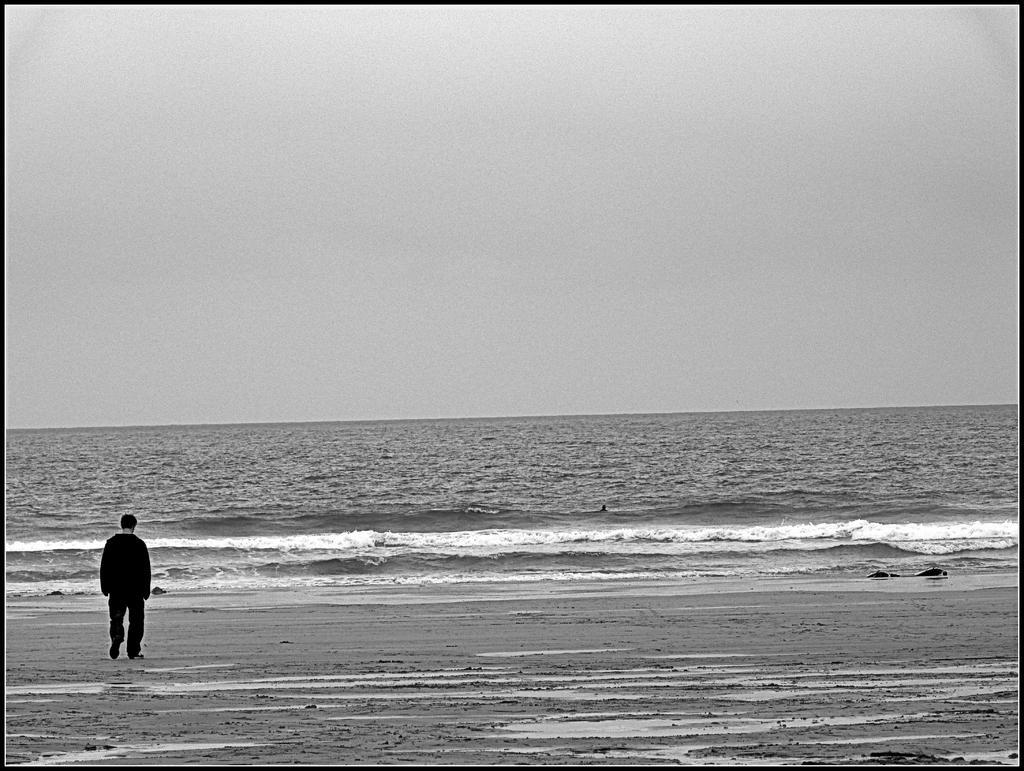Please provide a concise description of this image. This is a black and white picture, in this image we can see a person standing on the seashore, in the background we can see the sky. 